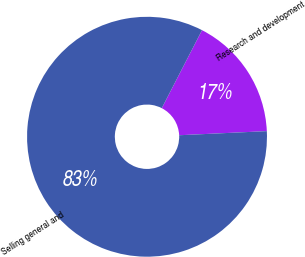<chart> <loc_0><loc_0><loc_500><loc_500><pie_chart><fcel>Research and development<fcel>Selling general and<nl><fcel>16.67%<fcel>83.33%<nl></chart> 